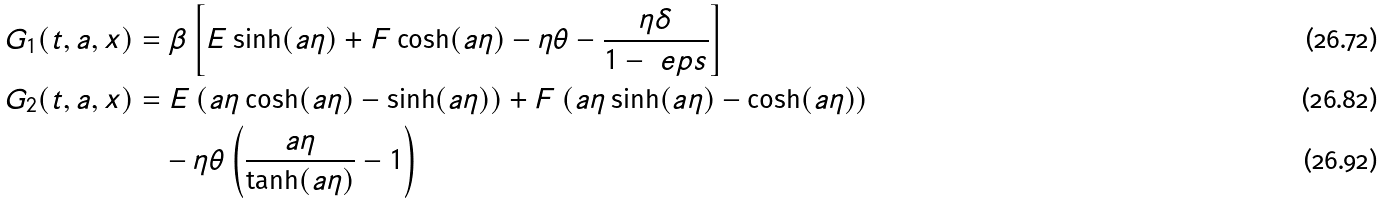<formula> <loc_0><loc_0><loc_500><loc_500>G _ { 1 } ( t , a , x ) & = \beta \left [ E \sinh ( a \eta ) + F \cosh ( a \eta ) - \eta \theta - \frac { \eta \delta } { 1 - \ e p s } \right ] \\ G _ { 2 } ( t , a , x ) & = E \left ( a \eta \cosh ( a \eta ) - \sinh ( a \eta ) \right ) + F \left ( a \eta \sinh ( a \eta ) - \cosh ( a \eta ) \right ) \\ & \quad - \eta \theta \left ( \frac { a \eta } { \tanh ( a \eta ) } - 1 \right )</formula> 